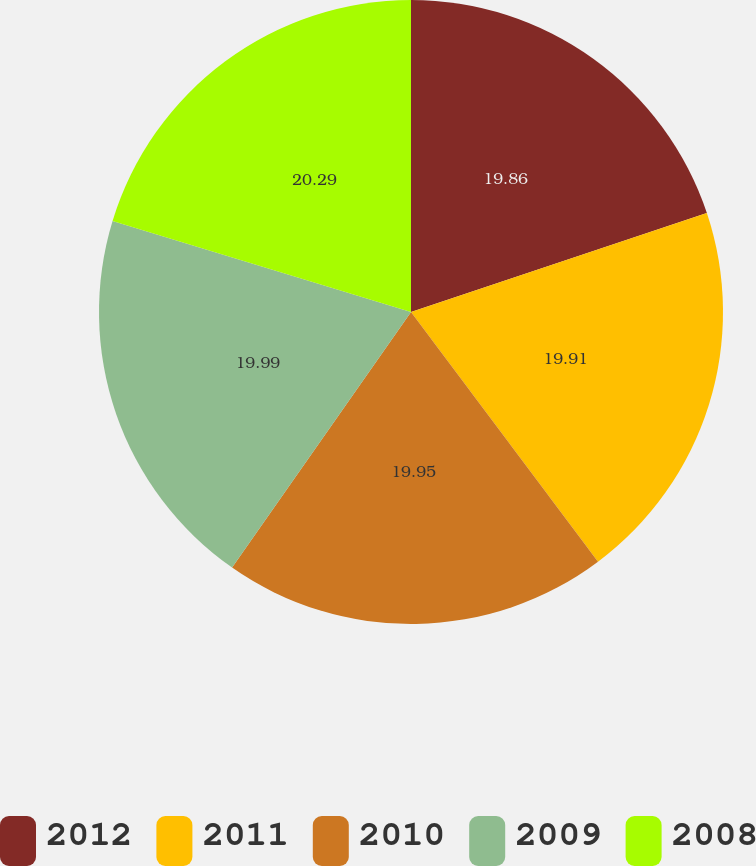Convert chart to OTSL. <chart><loc_0><loc_0><loc_500><loc_500><pie_chart><fcel>2012<fcel>2011<fcel>2010<fcel>2009<fcel>2008<nl><fcel>19.86%<fcel>19.91%<fcel>19.95%<fcel>19.99%<fcel>20.29%<nl></chart> 